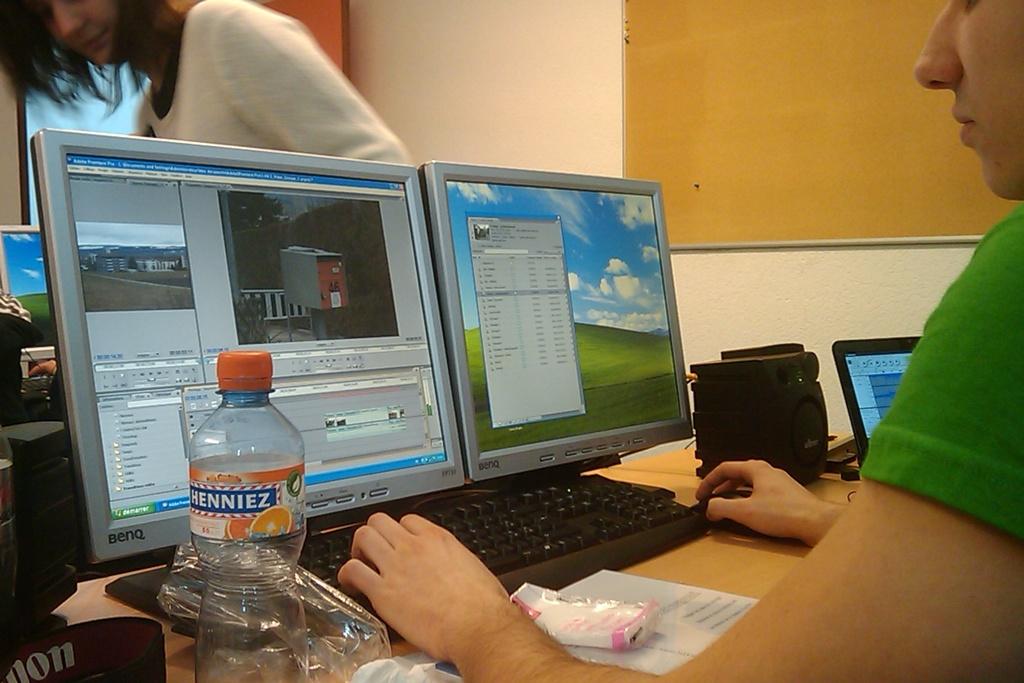What brand is on the bottle?
Keep it short and to the point. Henniez. 